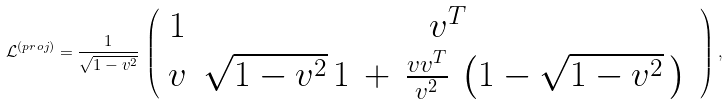Convert formula to latex. <formula><loc_0><loc_0><loc_500><loc_500>\mathcal { L } ^ { ( p r o j ) } = \frac { 1 } { \sqrt { 1 - v ^ { 2 } } } \, \left ( \begin{array} { c c } { 1 } & { { v ^ { T } } } \\ { { v } } & { { \sqrt { 1 - v ^ { 2 } } \, { 1 } \, + \, \frac { v v ^ { T } } { v ^ { 2 } } \, \left ( 1 - \sqrt { 1 - v ^ { 2 } } \, \right ) \, } } \end{array} \right ) ,</formula> 